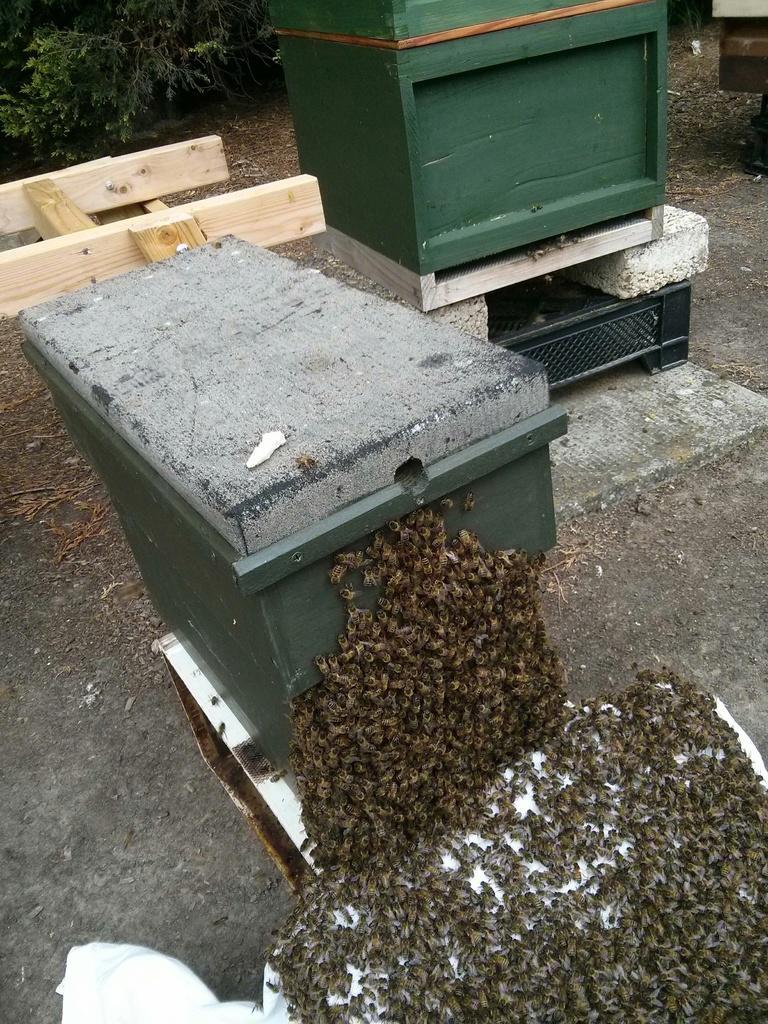Could you give a brief overview of what you see in this image? In this image we can see wooden boxes and there are bees. In the background there is a bench and a tree. 